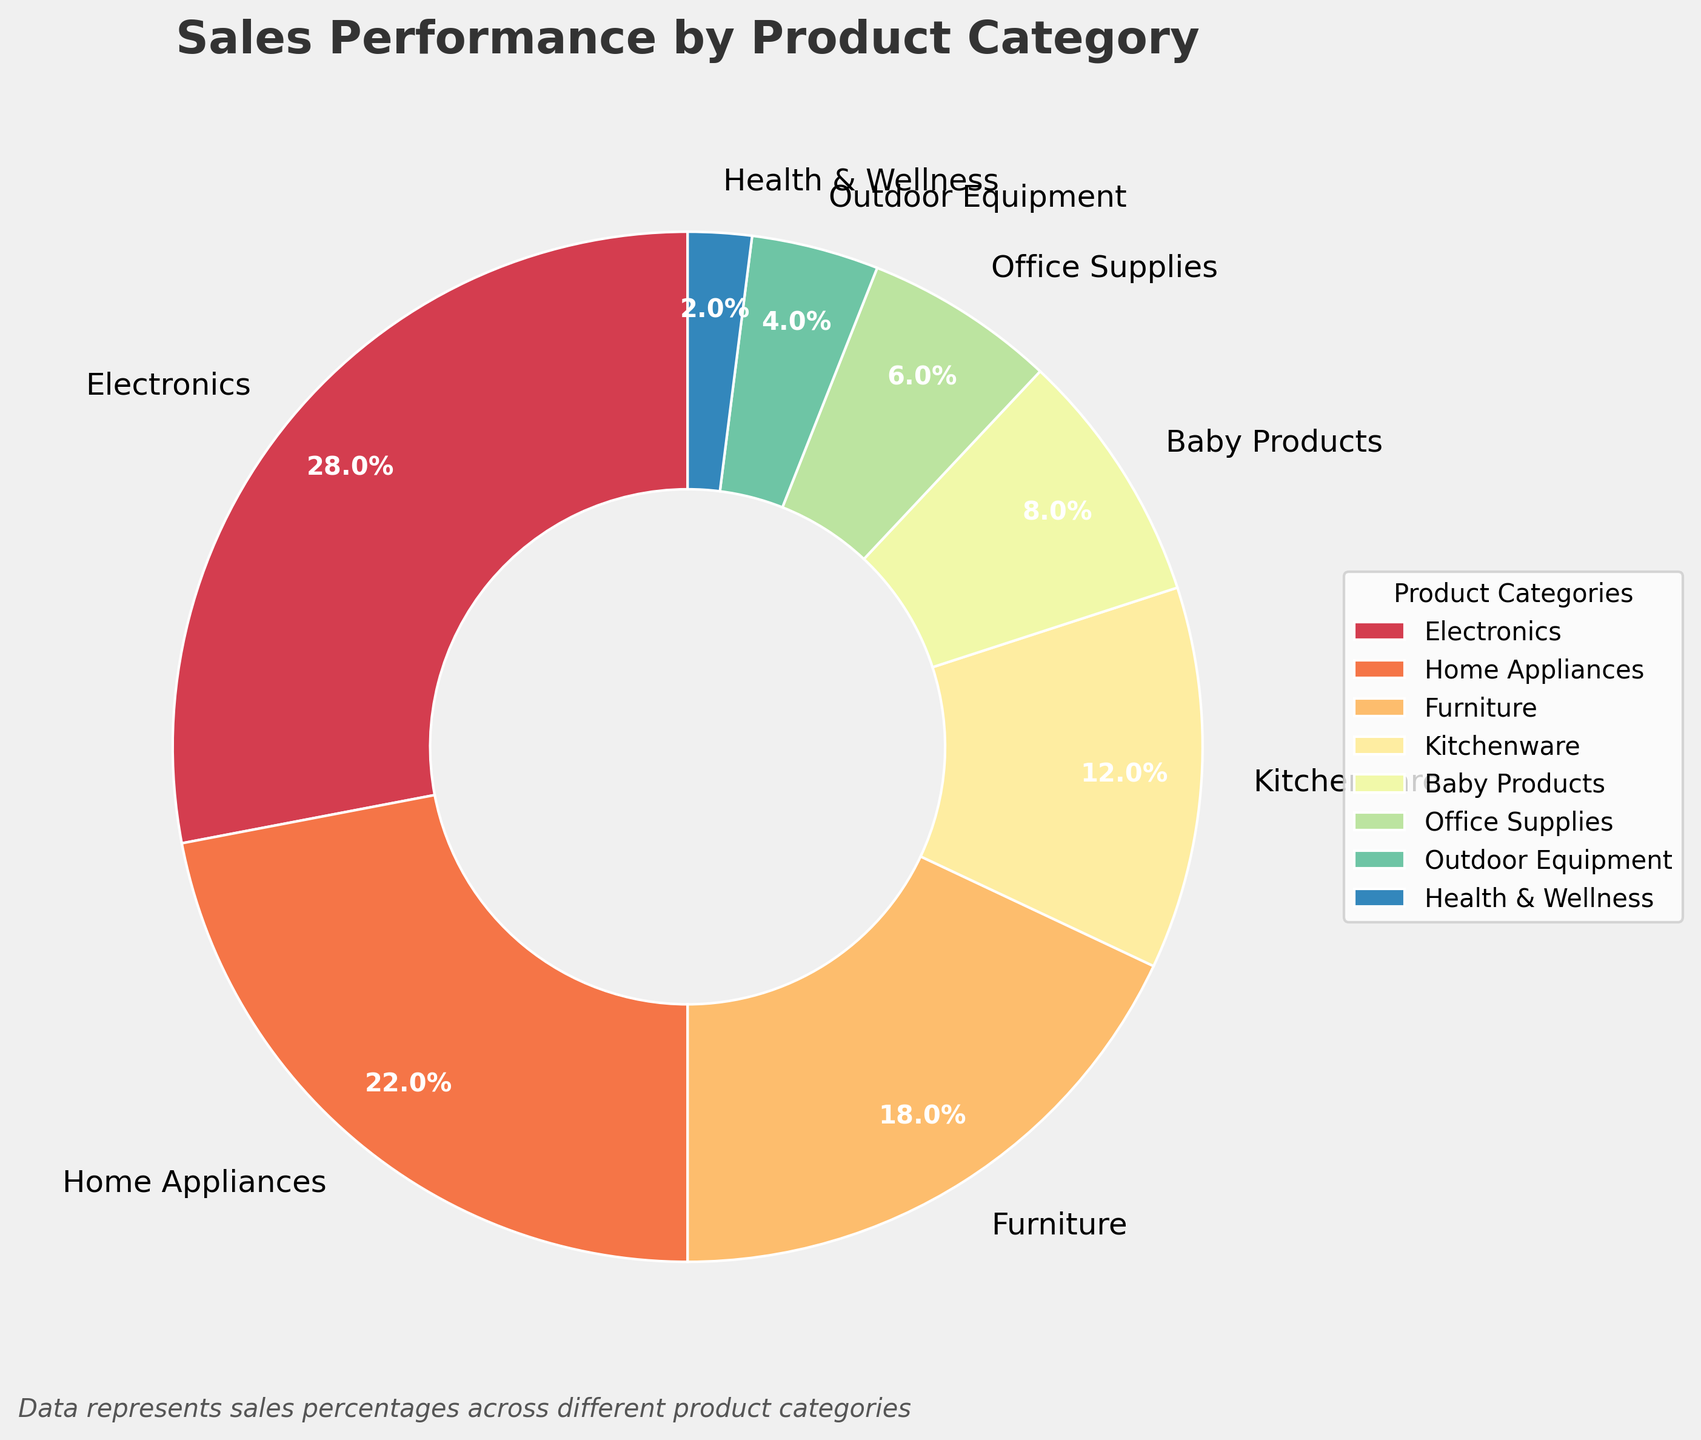Which product category has the highest sales percentage? To find the category with the highest sales percentage, look for the largest segment in the pie chart. The "Electronics" category covers 28%, which is the largest percentage.
Answer: Electronics Which product category has the lowest sales percentage? To identify the category with the lowest sales percentage, find the smallest segment in the pie chart. The "Health & Wellness" category covers only 2%, which is the smallest percentage.
Answer: Health & Wellness What is the combined sales percentage for Furniture and Kitchenware? Add the sales percentages of "Furniture" (18%) and "Kitchenware" (12%). 18% + 12% equals 30%.
Answer: 30% Are the sales percentages for Home Appliances and Furniture equal? Compare the sales percentages of "Home Appliances" and "Furniture". Home Appliances have 22%, and Furniture has 18%. Thus, they are not equal as 22% is greater than 18%.
Answer: No Which product categories make up more than 20% of the total sales? Identify the segments whose sales percentages are greater than 20%. "Electronics" (28%) and "Home Appliances" (22%) are the only categories that meet this criterion.
Answer: Electronics, Home Appliances What is the difference in sales percentage between Baby Products and Office Supplies? Subtract the sales percentage of Office Supplies (6%) from Baby Products (8%). 8% - 6% equals 2%.
Answer: 2% What is the average sales percentage of Health & Wellness and Outdoor Equipment? Add the sales percentages of "Health & Wellness" (2%) and "Outdoor Equipment" (4%), then divide by 2. (2% + 4%) / 2 equals 3%.
Answer: 3% Do Home Appliances and Kitchenware combined make up more sales than Furniture alone? Add the sales percentages of "Home Appliances" (22%) and "Kitchenware" (12%) and compare to the percentage of "Furniture" (18%). 22% + 12% = 34%, which is greater than 18%.
Answer: Yes Which product category is represented by a segment with a dark purple color? The dark purple color in the pie chart represents the "Electronics" category.
Answer: Electronics How many product categories have a sales percentage less than 10%? Identify segments in the pie chart with sales percentages under 10%. "Baby Products" (8%), "Office Supplies" (6%), "Outdoor Equipment" (4%), and "Health & Wellness" (2%) belong to this group, making it four categories.
Answer: Four 